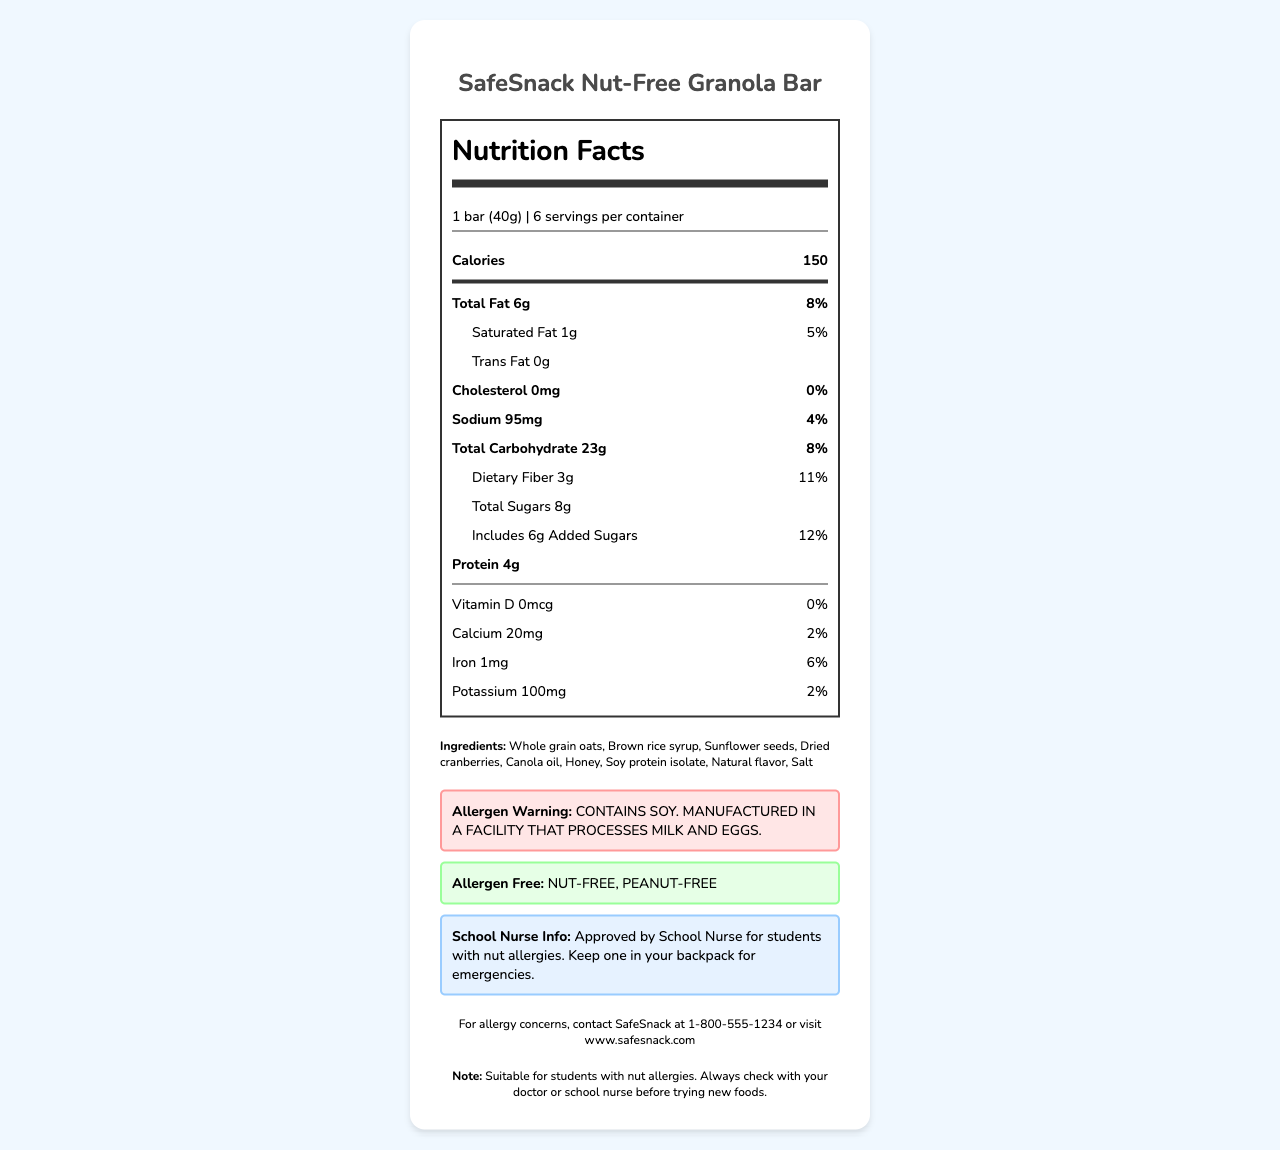what is the total fat content per serving? The label lists the total fat per serving as 6g.
Answer: 6g how many grams of dietary fiber are in one bar? The label mentions that the dietary fiber amount per serving is 3g.
Answer: 3g what percentage of daily value is the added sugars? The label indicates that the added sugars make up 12% of the daily value.
Answer: 12% is this granola bar nut-free? The allergen-free statement explicitly states that the product is nut-free and peanut-free.
Answer: Yes how many calories are in one serving of the granola bar? The calorie content per serving is listed as 150 calories.
Answer: 150 which nutrient has the highest percentage of daily value? A. Dietary Fiber B. Total Fat C. Sodium D. Iron Dietary fiber has the highest daily value percentage at 11%.
Answer: A what ingredient is listed first? A. Brown rice syrup B. Whole grain oats C. Sunflower seeds D. Soy protein isolate The first ingredient listed is Whole grain oats.
Answer: B is the granola bar high in sodium? The sodium content per serving is only 95mg, which is 4% of the daily value.
Answer: No summarize the main information provided in the document. The label details the nutritional content like calories, fat, sodium, carbohydrate, and protein per serving, along with ingredients and allergen information, including approval by school nurses, making it suitable for students with nut allergies.
Answer: The document is a nutrition facts label for the SafeSnack Nut-Free Granola Bar, highlighting its nutritional content per serving, ingredients, allergen warnings, and special notes for students with nut allergies approved by school nurses. It also includes the manufacturer's contact information. what is the protein content of the granola bar? The label lists the protein content as 4g per serving.
Answer: 4g what is the source of the contact information in the document? The manufacturer contact information states to contact SafeSnack at 1-800-555-1234 or visit www.safesnack.com.
Answer: SafeSnack are there any ingredients that contain dairy? The document only states that the product is manufactured in a facility that processes milk and eggs, but it doesn't confirm whether the ingredients themselves contain dairy.
Answer: Cannot be determined what is the percentage of daily value for calcium? The label indicates that the calcium content is 20mg, which is 2% of the daily value.
Answer: 2% what is the size of one granola bar serving? The serving size is specified as 1 bar, which is equivalent to 40g.
Answer: 1 bar (40g) 